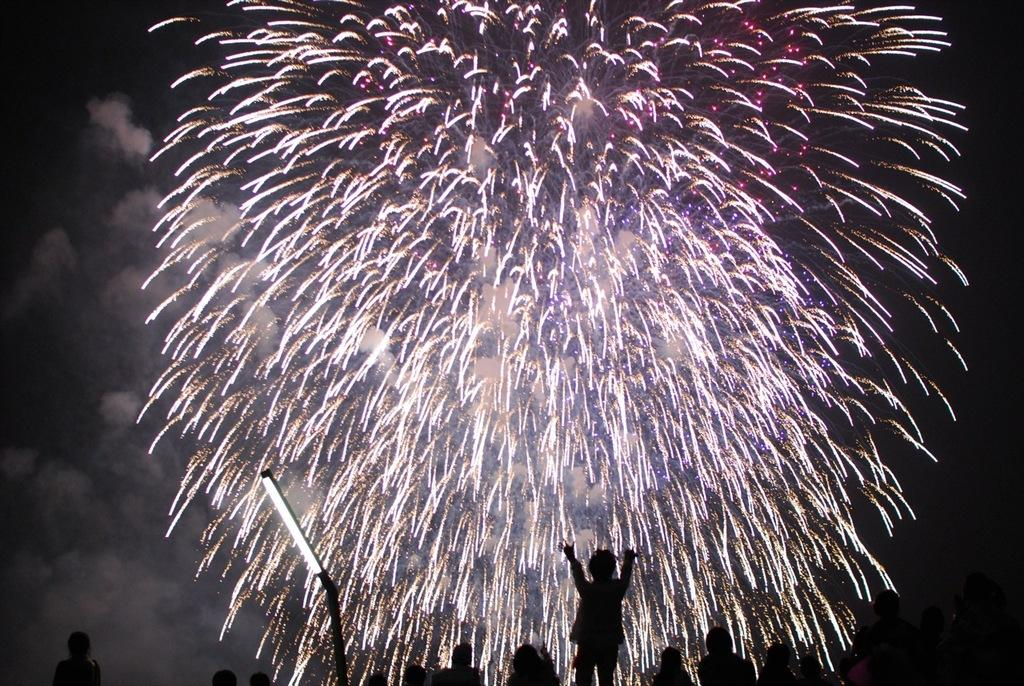Who or what is present in the image? There are people in the image. What can be seen illuminating the scene? There is a light in the image. What additional visual elements are present? Sparkles are visible in the image. How would you describe the overall lighting or setting of the image? The image appears to be in a darker setting. What type of farm animals can be seen in the image? There are no farm animals present in the image. What kind of paper is being used by the people in the image? There is no paper visible in the image. 